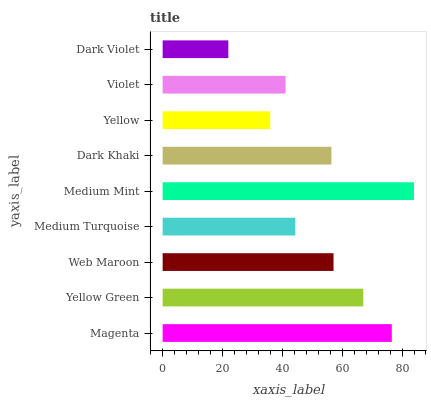Is Dark Violet the minimum?
Answer yes or no. Yes. Is Medium Mint the maximum?
Answer yes or no. Yes. Is Yellow Green the minimum?
Answer yes or no. No. Is Yellow Green the maximum?
Answer yes or no. No. Is Magenta greater than Yellow Green?
Answer yes or no. Yes. Is Yellow Green less than Magenta?
Answer yes or no. Yes. Is Yellow Green greater than Magenta?
Answer yes or no. No. Is Magenta less than Yellow Green?
Answer yes or no. No. Is Dark Khaki the high median?
Answer yes or no. Yes. Is Dark Khaki the low median?
Answer yes or no. Yes. Is Medium Mint the high median?
Answer yes or no. No. Is Web Maroon the low median?
Answer yes or no. No. 